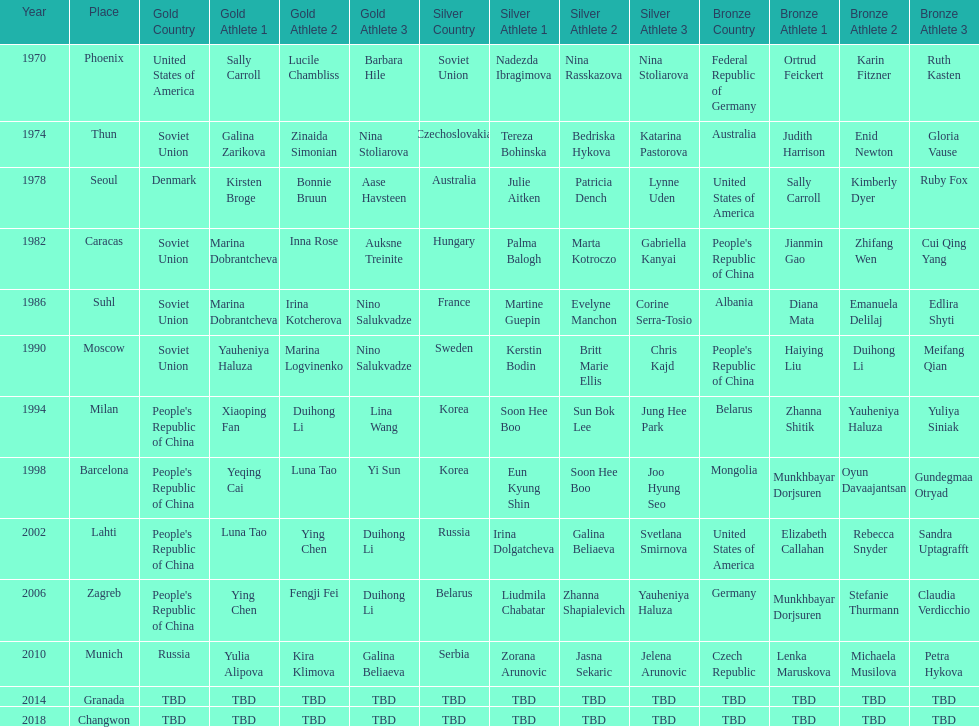Can you parse all the data within this table? {'header': ['Year', 'Place', 'Gold Country', 'Gold Athlete 1', 'Gold Athlete 2', 'Gold Athlete 3', 'Silver Country', 'Silver Athlete 1', 'Silver Athlete 2', 'Silver Athlete 3', 'Bronze Country', 'Bronze Athlete 1', 'Bronze Athlete 2', 'Bronze Athlete 3'], 'rows': [['1970', 'Phoenix', 'United States of America', 'Sally Carroll', 'Lucile Chambliss', 'Barbara Hile', 'Soviet Union', 'Nadezda Ibragimova', 'Nina Rasskazova', 'Nina Stoliarova', 'Federal Republic of Germany', 'Ortrud Feickert', 'Karin Fitzner', 'Ruth Kasten'], ['1974', 'Thun', 'Soviet Union', 'Galina Zarikova', 'Zinaida Simonian', 'Nina Stoliarova', 'Czechoslovakia', 'Tereza Bohinska', 'Bedriska Hykova', 'Katarina Pastorova', 'Australia', 'Judith Harrison', 'Enid Newton', 'Gloria Vause'], ['1978', 'Seoul', 'Denmark', 'Kirsten Broge', 'Bonnie Bruun', 'Aase Havsteen', 'Australia', 'Julie Aitken', 'Patricia Dench', 'Lynne Uden', 'United States of America', 'Sally Carroll', 'Kimberly Dyer', 'Ruby Fox'], ['1982', 'Caracas', 'Soviet Union', 'Marina Dobrantcheva', 'Inna Rose', 'Auksne Treinite', 'Hungary', 'Palma Balogh', 'Marta Kotroczo', 'Gabriella Kanyai', "People's Republic of China", 'Jianmin Gao', 'Zhifang Wen', 'Cui Qing Yang'], ['1986', 'Suhl', 'Soviet Union', 'Marina Dobrantcheva', 'Irina Kotcherova', 'Nino Salukvadze', 'France', 'Martine Guepin', 'Evelyne Manchon', 'Corine Serra-Tosio', 'Albania', 'Diana Mata', 'Emanuela Delilaj', 'Edlira Shyti'], ['1990', 'Moscow', 'Soviet Union', 'Yauheniya Haluza', 'Marina Logvinenko', 'Nino Salukvadze', 'Sweden', 'Kerstin Bodin', 'Britt Marie Ellis', 'Chris Kajd', "People's Republic of China", 'Haiying Liu', 'Duihong Li', 'Meifang Qian'], ['1994', 'Milan', "People's Republic of China", 'Xiaoping Fan', 'Duihong Li', 'Lina Wang', 'Korea', 'Soon Hee Boo', 'Sun Bok Lee', 'Jung Hee Park', 'Belarus', 'Zhanna Shitik', 'Yauheniya Haluza', 'Yuliya Siniak'], ['1998', 'Barcelona', "People's Republic of China", 'Yeqing Cai', 'Luna Tao', 'Yi Sun', 'Korea', 'Eun Kyung Shin', 'Soon Hee Boo', 'Joo Hyung Seo', 'Mongolia', 'Munkhbayar Dorjsuren', 'Oyun Davaajantsan', 'Gundegmaa Otryad'], ['2002', 'Lahti', "People's Republic of China", 'Luna Tao', 'Ying Chen', 'Duihong Li', 'Russia', 'Irina Dolgatcheva', 'Galina Beliaeva', 'Svetlana Smirnova', 'United States of America', 'Elizabeth Callahan', 'Rebecca Snyder', 'Sandra Uptagrafft'], ['2006', 'Zagreb', "People's Republic of China", 'Ying Chen', 'Fengji Fei', 'Duihong Li', 'Belarus', 'Liudmila Chabatar', 'Zhanna Shapialevich', 'Yauheniya Haluza', 'Germany', 'Munkhbayar Dorjsuren', 'Stefanie Thurmann', 'Claudia Verdicchio'], ['2010', 'Munich', 'Russia', 'Yulia Alipova', 'Kira Klimova', 'Galina Beliaeva', 'Serbia', 'Zorana Arunovic', 'Jasna Sekaric', 'Jelena Arunovic', 'Czech Republic', 'Lenka Maruskova', 'Michaela Musilova', 'Petra Hykova'], ['2014', 'Granada', 'TBD', 'TBD', 'TBD', 'TBD', 'TBD', 'TBD', 'TBD', 'TBD', 'TBD', 'TBD', 'TBD', 'TBD'], ['2018', 'Changwon', 'TBD', 'TBD', 'TBD', 'TBD', 'TBD', 'TBD', 'TBD', 'TBD', 'TBD', 'TBD', 'TBD', 'TBD']]} What are the total number of times the soviet union is listed under the gold column? 4. 